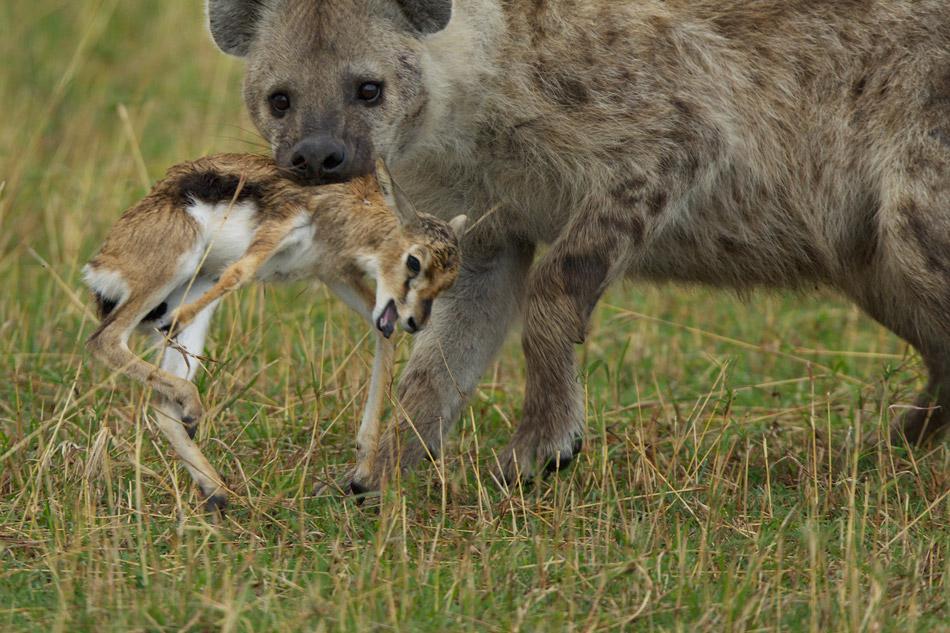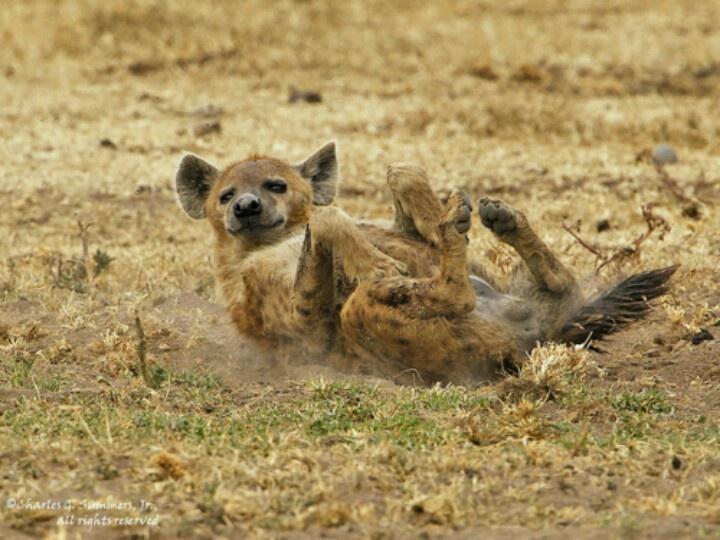The first image is the image on the left, the second image is the image on the right. For the images shown, is this caption "An image shows a wild dog with its meal of prey." true? Answer yes or no. Yes. The first image is the image on the left, the second image is the image on the right. Assess this claim about the two images: "there are at least two hyenas in the image on the left". Correct or not? Answer yes or no. No. 